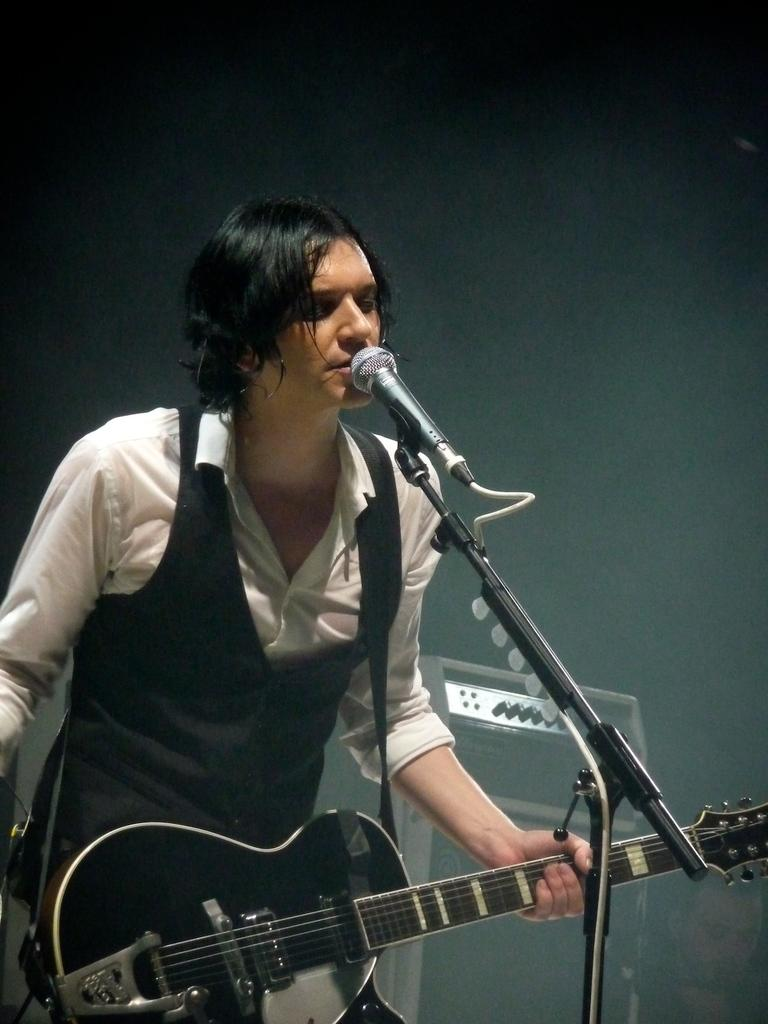What is the person in the image doing? The person is playing a guitar. What is the person wearing in the image? The person is wearing a white shirt. What object is in front of the person? There is a microphone in front of the person. What can be seen in the background of the image? There is a sound box in the background of the image. Where are the children playing on the playground in the image? There are no children or playground present in the image. 